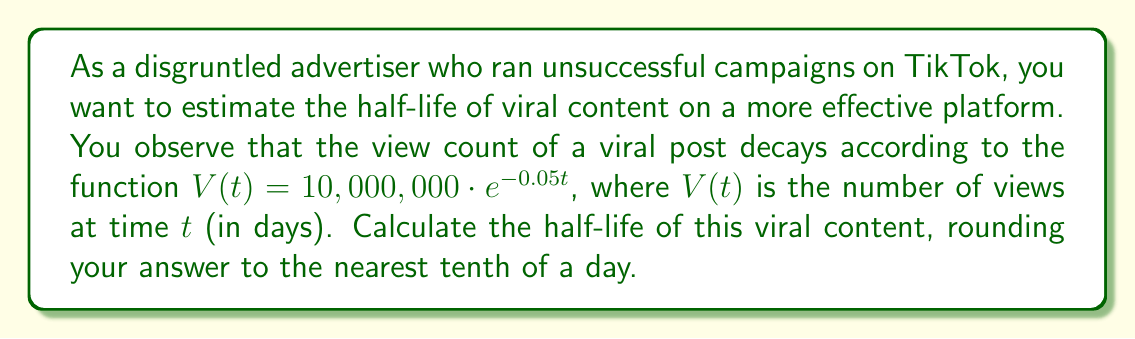Could you help me with this problem? To solve this problem, we need to use the properties of logarithmic decay functions and the concept of half-life.

1) The half-life is the time it takes for the quantity to decrease to half of its original value. In this case, we need to find $t$ when $V(t) = 5,000,000$ (half of the initial 10,000,000 views).

2) We can set up the equation:

   $5,000,000 = 10,000,000 \cdot e^{-0.05t}$

3) Simplify by dividing both sides by 10,000,000:

   $\frac{1}{2} = e^{-0.05t}$

4) Take the natural logarithm of both sides:

   $\ln(\frac{1}{2}) = \ln(e^{-0.05t})$

5) Simplify the right side using the properties of logarithms:

   $\ln(\frac{1}{2}) = -0.05t$

6) Solve for $t$:

   $t = \frac{\ln(\frac{1}{2})}{-0.05} = \frac{-\ln(2)}{0.05}$

7) Calculate the value:

   $t = \frac{-(-0.693147...)}{0.05} \approx 13.86294...$

8) Rounding to the nearest tenth:

   $t \approx 13.9$ days
Answer: The half-life of the viral content is approximately 13.9 days. 